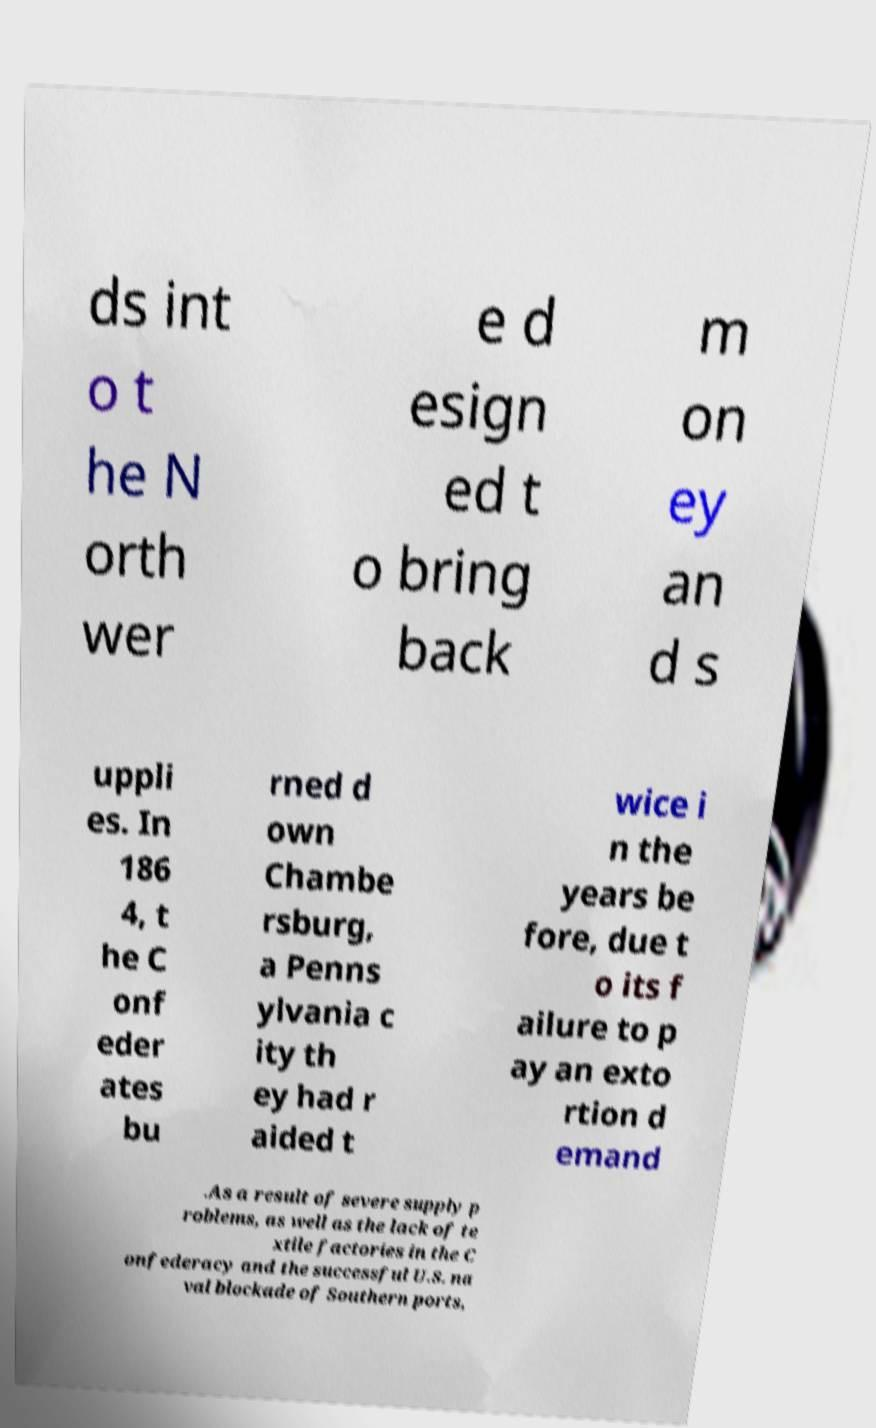Please read and relay the text visible in this image. What does it say? ds int o t he N orth wer e d esign ed t o bring back m on ey an d s uppli es. In 186 4, t he C onf eder ates bu rned d own Chambe rsburg, a Penns ylvania c ity th ey had r aided t wice i n the years be fore, due t o its f ailure to p ay an exto rtion d emand .As a result of severe supply p roblems, as well as the lack of te xtile factories in the C onfederacy and the successful U.S. na val blockade of Southern ports, 